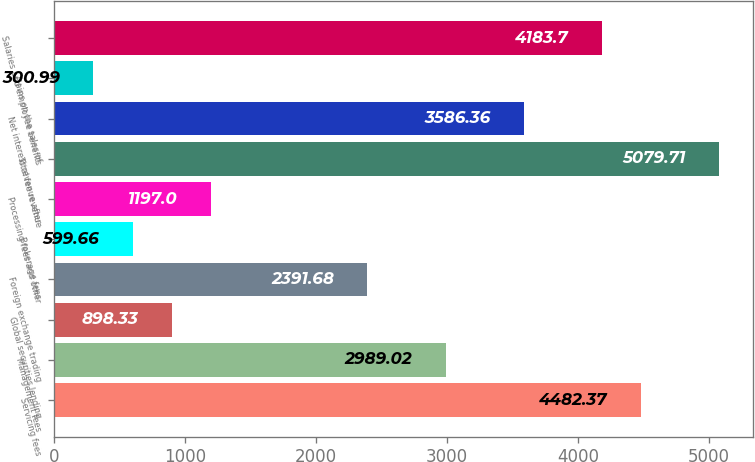<chart> <loc_0><loc_0><loc_500><loc_500><bar_chart><fcel>Servicing fees<fcel>Management fees<fcel>Global securities lending<fcel>Foreign exchange trading<fcel>Brokerage fees<fcel>Processing fees and other<fcel>Total fee revenue<fcel>Net interest revenue after<fcel>Gains on the sales of<fcel>Salaries and employee benefits<nl><fcel>4482.37<fcel>2989.02<fcel>898.33<fcel>2391.68<fcel>599.66<fcel>1197<fcel>5079.71<fcel>3586.36<fcel>300.99<fcel>4183.7<nl></chart> 